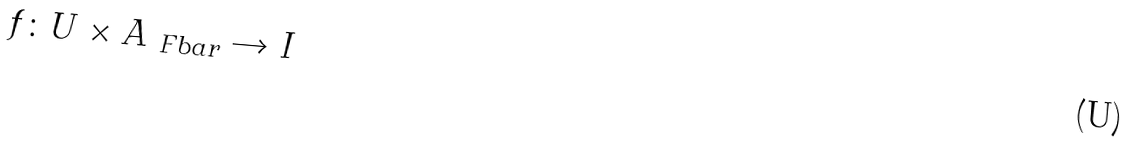Convert formula to latex. <formula><loc_0><loc_0><loc_500><loc_500>f \colon U \times A _ { \ F b a r } \rightarrow I</formula> 